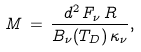Convert formula to latex. <formula><loc_0><loc_0><loc_500><loc_500>M \, = \, \frac { d ^ { 2 } \, F _ { \nu } \, R } { B _ { \nu } ( T _ { D } ) \, \kappa _ { \nu } } ,</formula> 